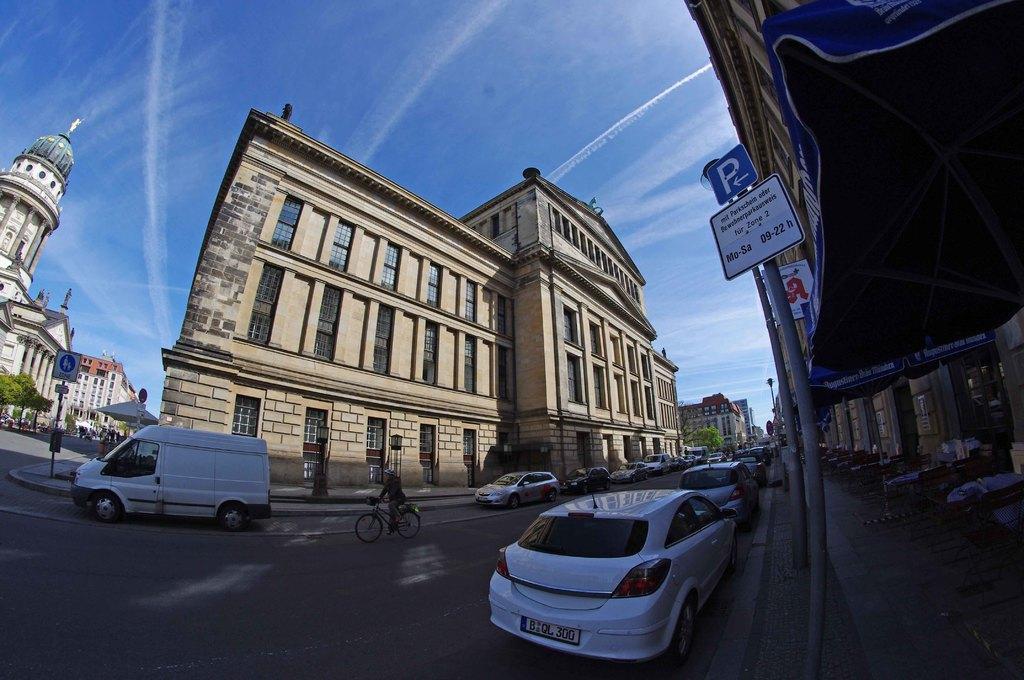Could you give a brief overview of what you see in this image? As we can see in the image there are buildings, sign poles, bicycle, vehicles, tree and windows. At the top there is sky. 